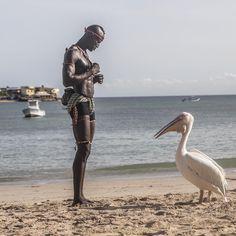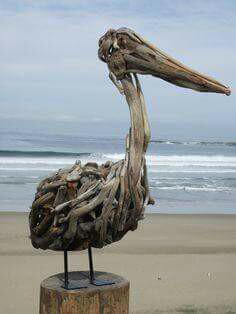The first image is the image on the left, the second image is the image on the right. For the images displayed, is the sentence "There is at least two birds in the left image." factually correct? Answer yes or no. No. The first image is the image on the left, the second image is the image on the right. Examine the images to the left and right. Is the description "At least one image contains multiple pelicans in the foreground, and at least one image shows pelicans with their beaks crossed." accurate? Answer yes or no. No. 